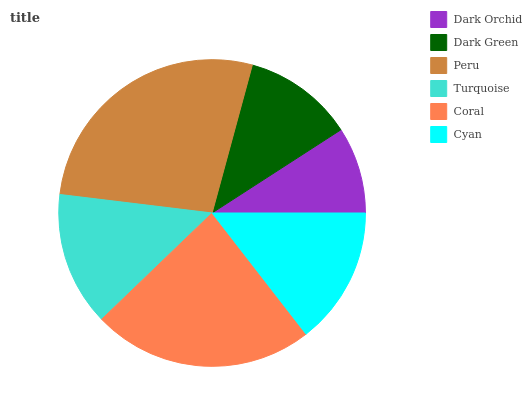Is Dark Orchid the minimum?
Answer yes or no. Yes. Is Peru the maximum?
Answer yes or no. Yes. Is Dark Green the minimum?
Answer yes or no. No. Is Dark Green the maximum?
Answer yes or no. No. Is Dark Green greater than Dark Orchid?
Answer yes or no. Yes. Is Dark Orchid less than Dark Green?
Answer yes or no. Yes. Is Dark Orchid greater than Dark Green?
Answer yes or no. No. Is Dark Green less than Dark Orchid?
Answer yes or no. No. Is Cyan the high median?
Answer yes or no. Yes. Is Turquoise the low median?
Answer yes or no. Yes. Is Peru the high median?
Answer yes or no. No. Is Dark Orchid the low median?
Answer yes or no. No. 